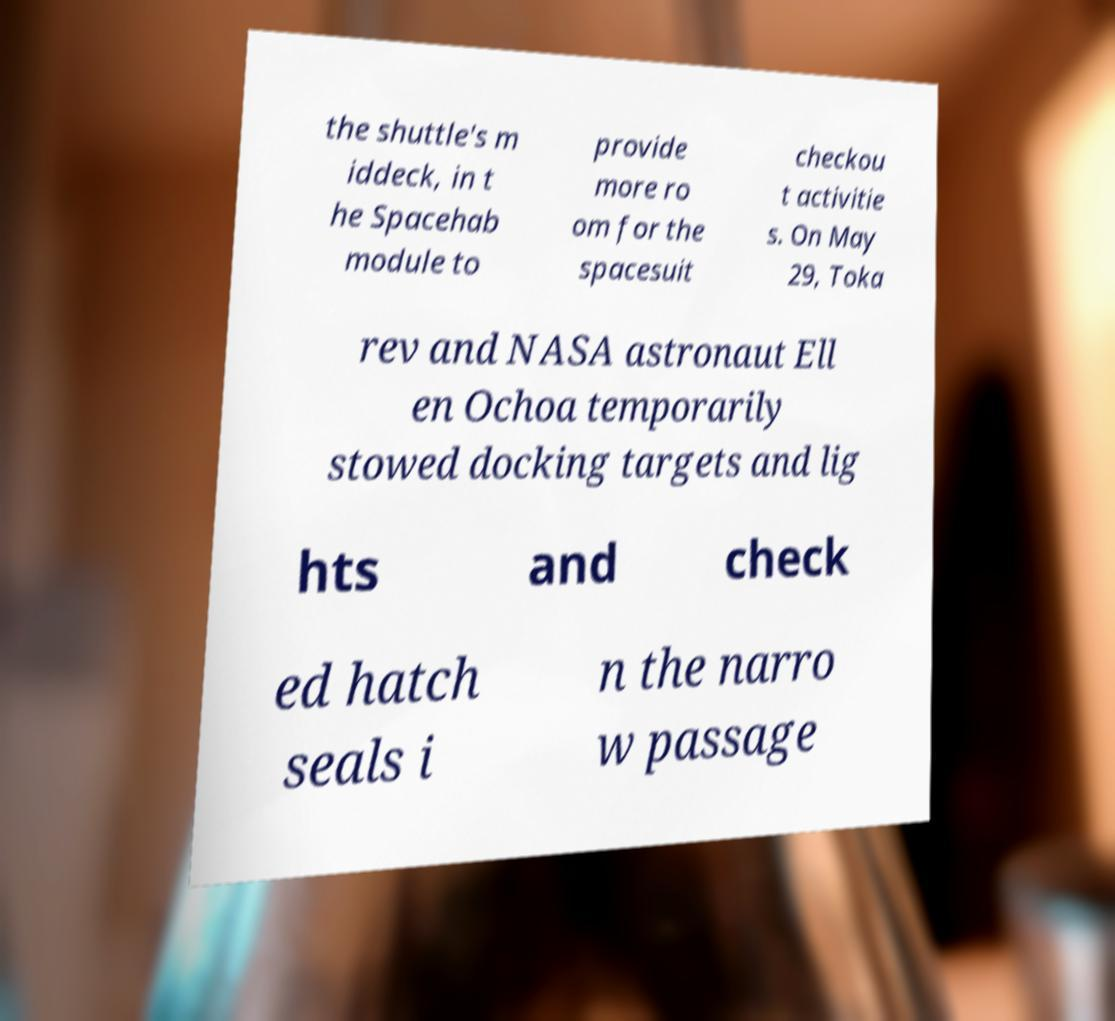There's text embedded in this image that I need extracted. Can you transcribe it verbatim? the shuttle's m iddeck, in t he Spacehab module to provide more ro om for the spacesuit checkou t activitie s. On May 29, Toka rev and NASA astronaut Ell en Ochoa temporarily stowed docking targets and lig hts and check ed hatch seals i n the narro w passage 